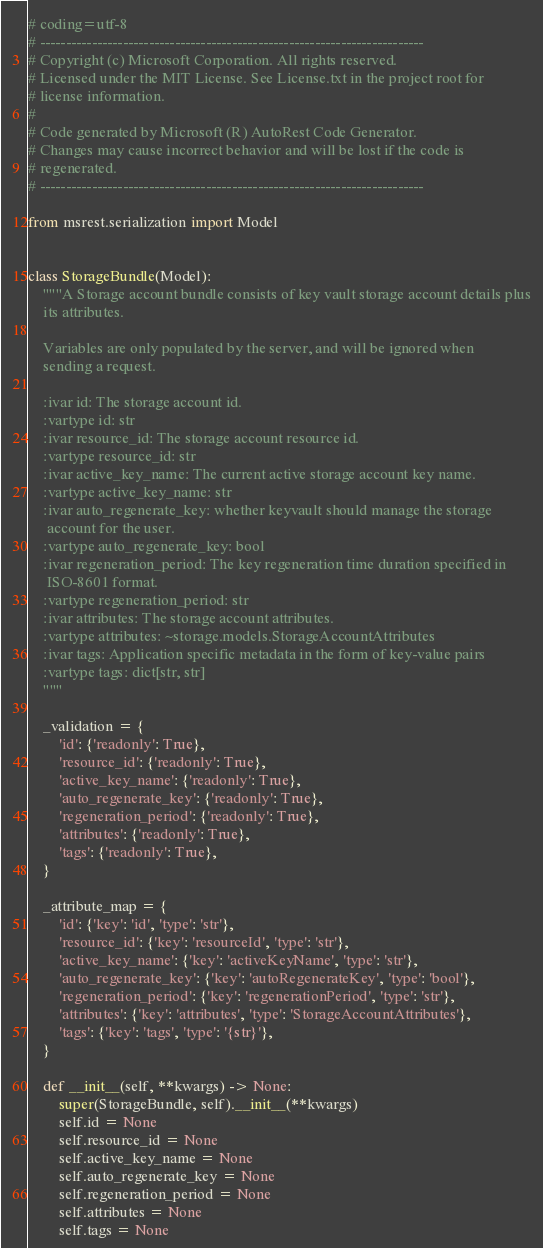<code> <loc_0><loc_0><loc_500><loc_500><_Python_># coding=utf-8
# --------------------------------------------------------------------------
# Copyright (c) Microsoft Corporation. All rights reserved.
# Licensed under the MIT License. See License.txt in the project root for
# license information.
#
# Code generated by Microsoft (R) AutoRest Code Generator.
# Changes may cause incorrect behavior and will be lost if the code is
# regenerated.
# --------------------------------------------------------------------------

from msrest.serialization import Model


class StorageBundle(Model):
    """A Storage account bundle consists of key vault storage account details plus
    its attributes.

    Variables are only populated by the server, and will be ignored when
    sending a request.

    :ivar id: The storage account id.
    :vartype id: str
    :ivar resource_id: The storage account resource id.
    :vartype resource_id: str
    :ivar active_key_name: The current active storage account key name.
    :vartype active_key_name: str
    :ivar auto_regenerate_key: whether keyvault should manage the storage
     account for the user.
    :vartype auto_regenerate_key: bool
    :ivar regeneration_period: The key regeneration time duration specified in
     ISO-8601 format.
    :vartype regeneration_period: str
    :ivar attributes: The storage account attributes.
    :vartype attributes: ~storage.models.StorageAccountAttributes
    :ivar tags: Application specific metadata in the form of key-value pairs
    :vartype tags: dict[str, str]
    """

    _validation = {
        'id': {'readonly': True},
        'resource_id': {'readonly': True},
        'active_key_name': {'readonly': True},
        'auto_regenerate_key': {'readonly': True},
        'regeneration_period': {'readonly': True},
        'attributes': {'readonly': True},
        'tags': {'readonly': True},
    }

    _attribute_map = {
        'id': {'key': 'id', 'type': 'str'},
        'resource_id': {'key': 'resourceId', 'type': 'str'},
        'active_key_name': {'key': 'activeKeyName', 'type': 'str'},
        'auto_regenerate_key': {'key': 'autoRegenerateKey', 'type': 'bool'},
        'regeneration_period': {'key': 'regenerationPeriod', 'type': 'str'},
        'attributes': {'key': 'attributes', 'type': 'StorageAccountAttributes'},
        'tags': {'key': 'tags', 'type': '{str}'},
    }

    def __init__(self, **kwargs) -> None:
        super(StorageBundle, self).__init__(**kwargs)
        self.id = None
        self.resource_id = None
        self.active_key_name = None
        self.auto_regenerate_key = None
        self.regeneration_period = None
        self.attributes = None
        self.tags = None
</code> 